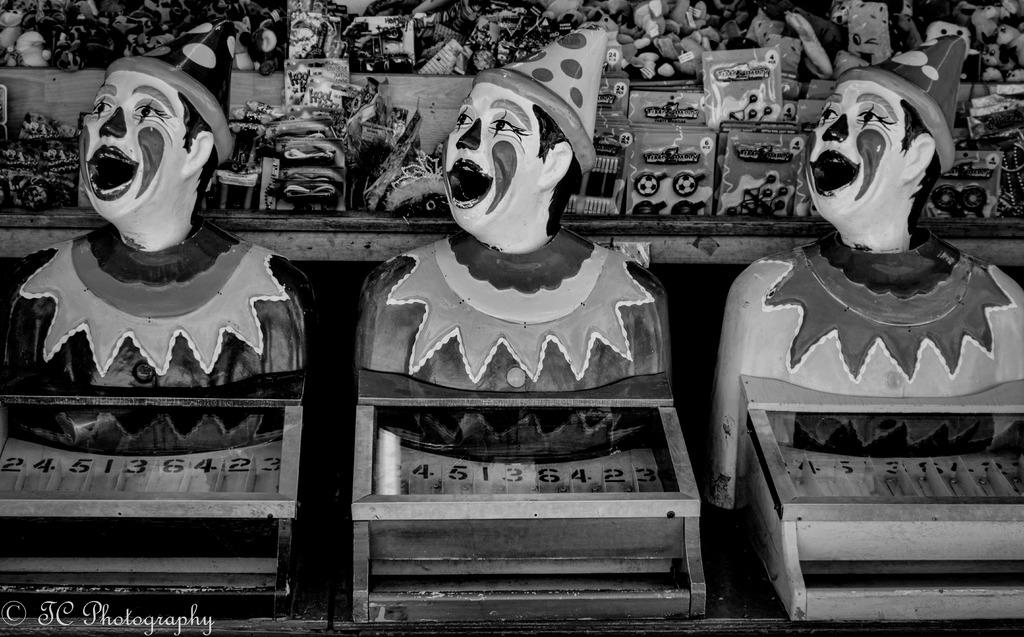What type of objects are the main subjects in the image? There are statues of a person in the image. What can be seen in the background of the image? There are toys and other objects in the background of the image. What is the color scheme of the image? The image is black and white. How many lizards are present in the image? There are no lizards present in the image. 